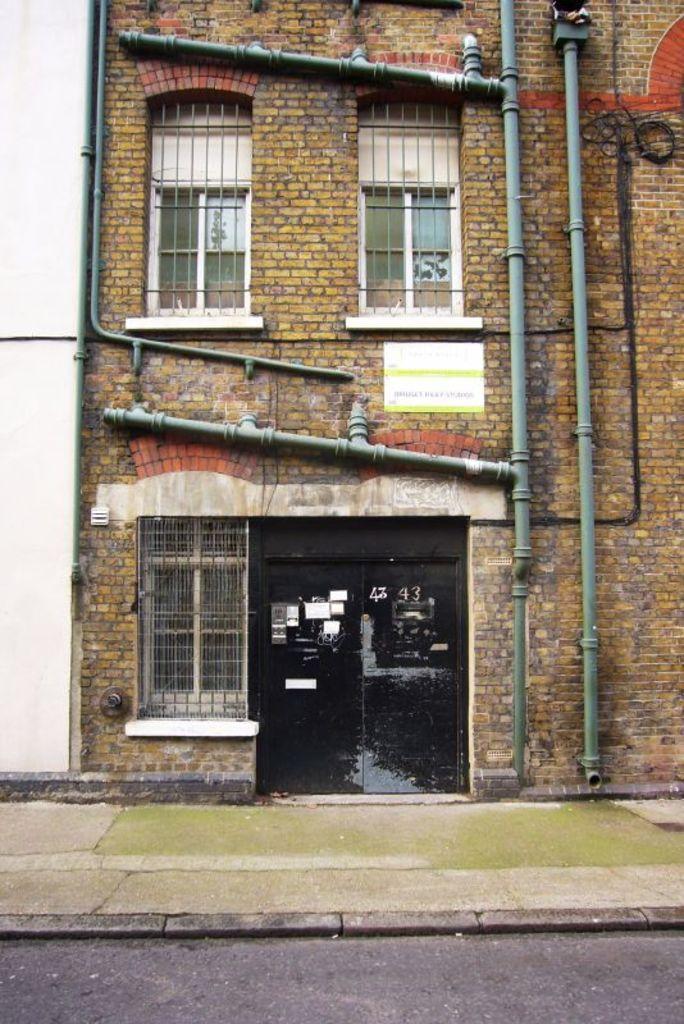Could you give a brief overview of what you see in this image? In this image I can see a building along with the windows. There are few pipes attached to the wall. Here I can see two glass doors. At the bottom there is a road. 